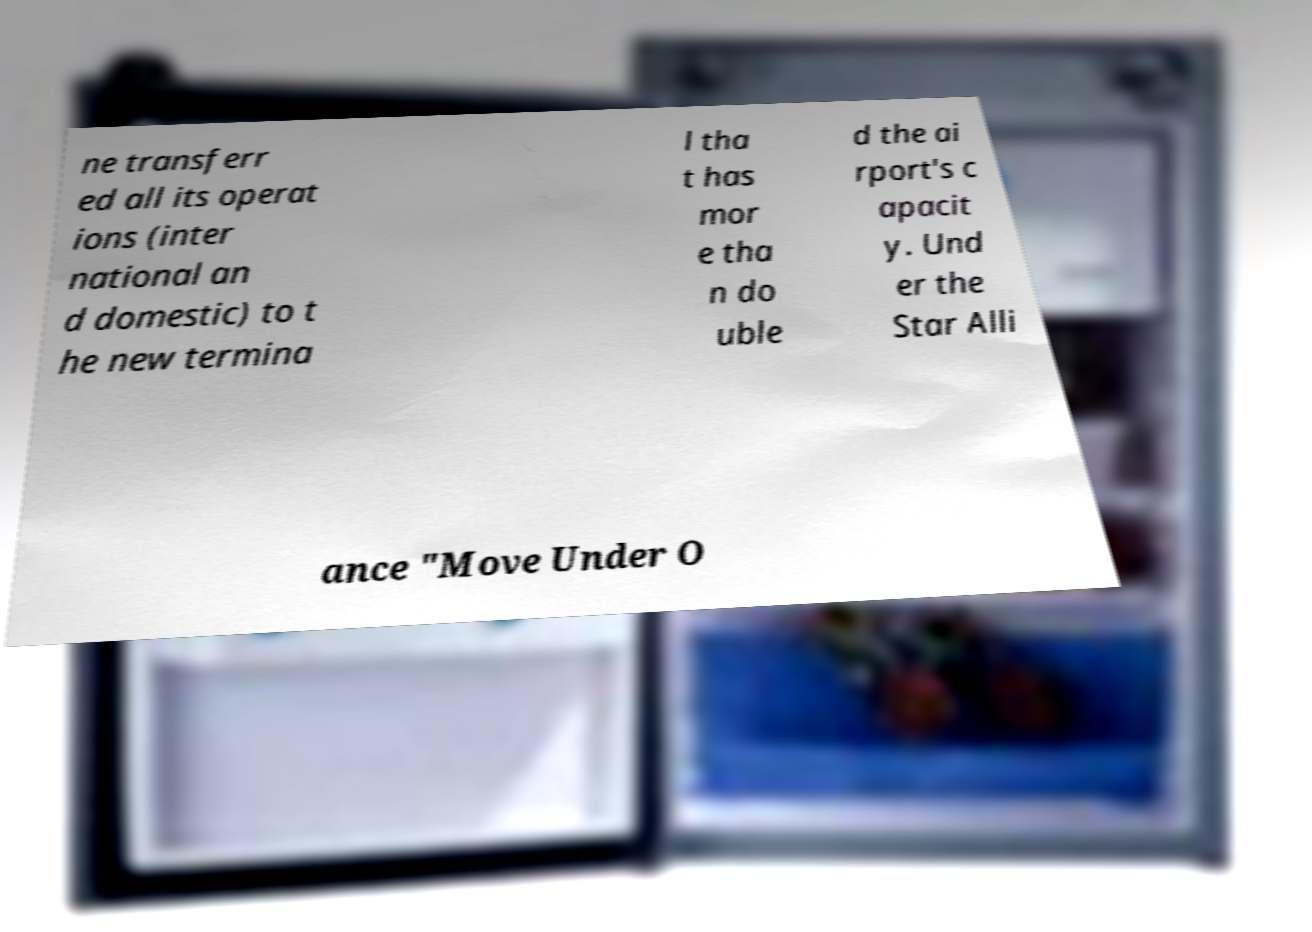What messages or text are displayed in this image? I need them in a readable, typed format. ne transferr ed all its operat ions (inter national an d domestic) to t he new termina l tha t has mor e tha n do uble d the ai rport's c apacit y. Und er the Star Alli ance "Move Under O 